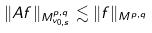Convert formula to latex. <formula><loc_0><loc_0><loc_500><loc_500>\| A f \| _ { M ^ { p , q } _ { v _ { 0 , s } } } \lesssim \| f \| _ { M ^ { p , q } }</formula> 